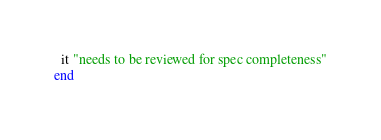Convert code to text. <code><loc_0><loc_0><loc_500><loc_500><_Ruby_>  it "needs to be reviewed for spec completeness"
end
</code> 